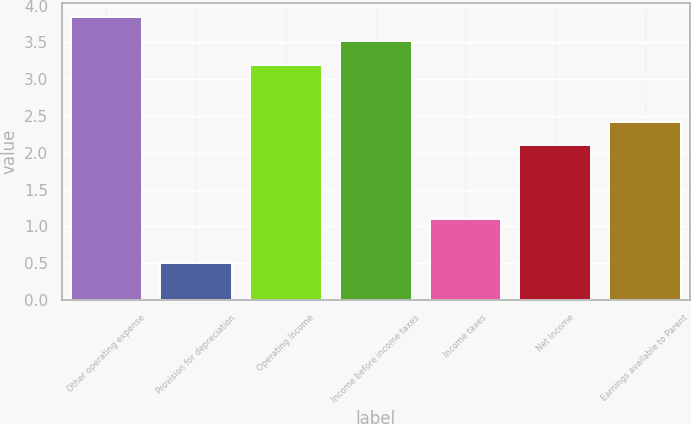Convert chart. <chart><loc_0><loc_0><loc_500><loc_500><bar_chart><fcel>Other operating expense<fcel>Provision for depreciation<fcel>Operating Income<fcel>Income before income taxes<fcel>Income taxes<fcel>Net Income<fcel>Earnings available to Parent<nl><fcel>3.84<fcel>0.5<fcel>3.2<fcel>3.52<fcel>1.1<fcel>2.1<fcel>2.42<nl></chart> 